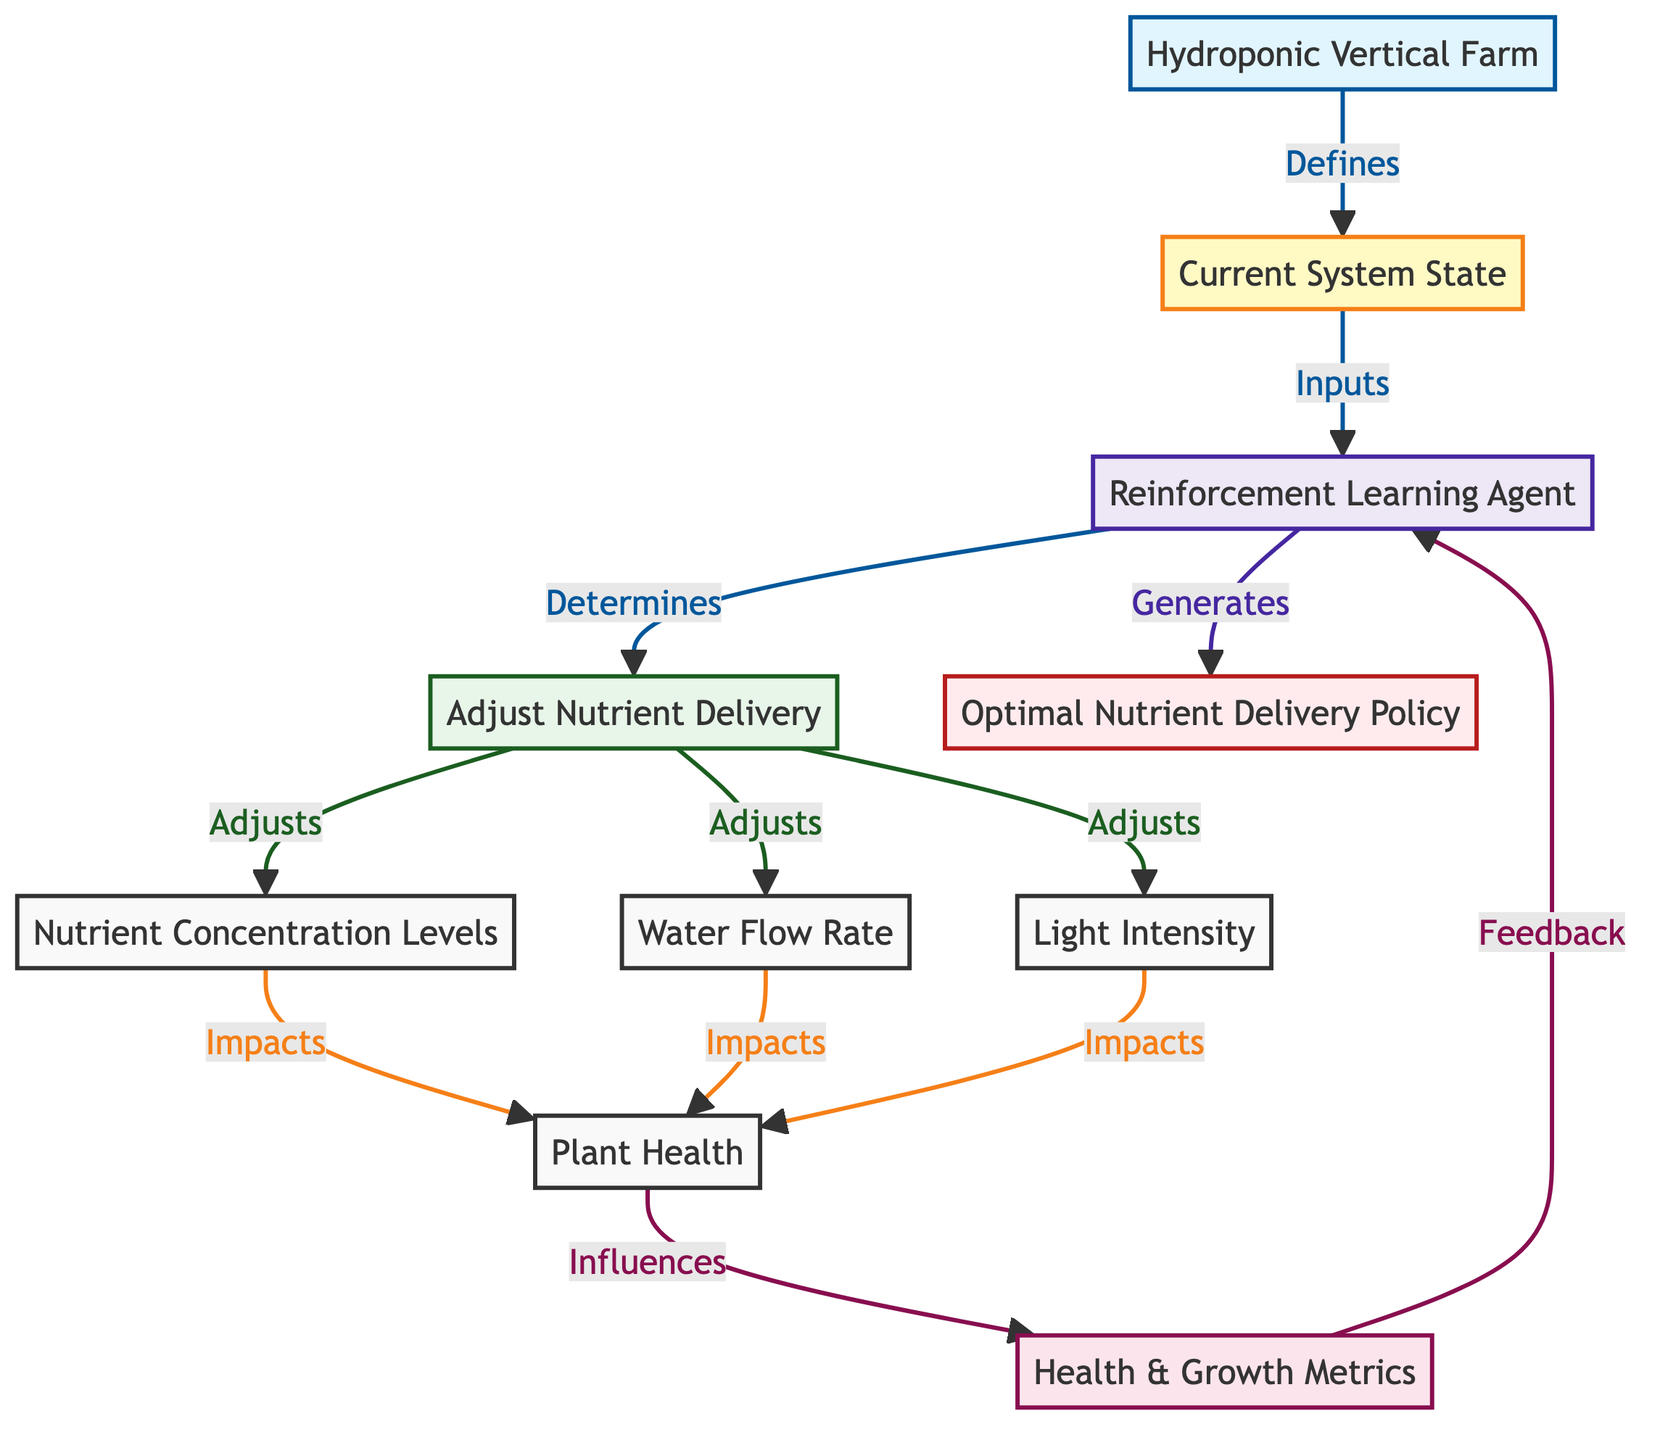What is the main environment depicted in the diagram? The diagram starts with the "Hydroponic Vertical Farm," which is the first node representing the overall environment that the system operates within.
Answer: Hydroponic Vertical Farm How many different states are represented in the diagram? There is only one state node labeled "Current System State" that describes the system's current condition before actions are determined.
Answer: One Which nodes influence the "Plant Health"? Three nodes: "Nutrient Concentration Levels," "Water Flow Rate," and "Light Intensity" all have directed arrows pointing towards "Plant Health," indicating their influence on it.
Answer: Nutrient Concentration Levels, Water Flow Rate, Light Intensity What feedback does the "Reward" node provide? The "Reward" node, which is based on "Health & Growth Metrics," provides feedback to the "Reinforcement Learning Agent," indicating how well the adjustments are performing based on plant health.
Answer: Feedback to Reinforcement Learning Agent What does the "Reinforcement Learning Agent" generate? The "Reinforcement Learning Agent" generates the "Optimal Nutrient Delivery Policy," which is derived from its training based on the rewards it receives from the state actions it undertakes.
Answer: Optimal Nutrient Delivery Policy Which action directly adjusts "Nutrient Delivery"? The action "Adjust Nutrient Delivery" is explicitly mentioned as the action taken by the agent to modify the nutrient concentrations, meaning it impacts the nutrient delivery directly.
Answer: Adjust Nutrient Delivery Explain the relationship that exists between "Plant Health" and "Reward." The "Plant Health" state influences the "Reward," meaning that the health metrics of the plants directly affect the reward that the agent receives for its decision-making process, guiding its learning.
Answer: Plant Health influences Reward How does the "Reinforcement Learning Agent" utilize the environment? The "Reinforcement Learning Agent" takes the "Current System State" defined by the environment as input to determine the best actions to take for nutrient delivery adjustments.
Answer: Utilizes Current System State What action is taken to influence "Nutrient Concentration Levels"? The action "Adjust Nutrient Delivery" is the specific action taken to directly influence "Nutrient Concentration Levels" as part of the agent's decision-making process.
Answer: Adjust Nutrient Delivery 